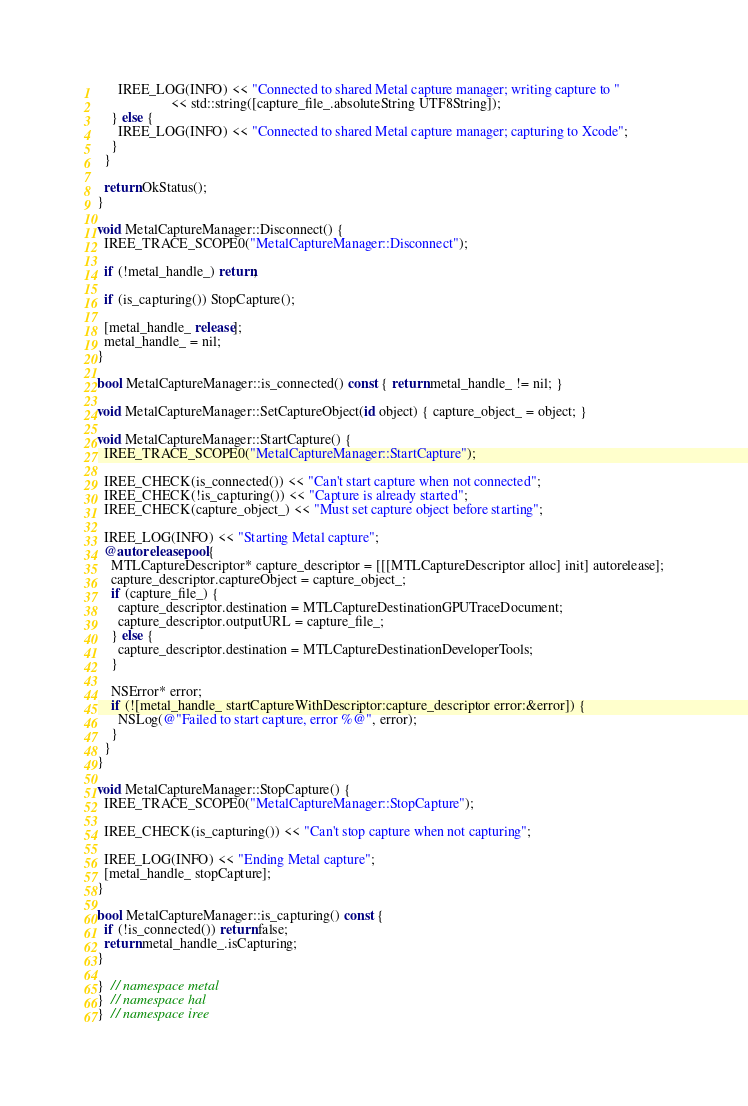Convert code to text. <code><loc_0><loc_0><loc_500><loc_500><_ObjectiveC_>      IREE_LOG(INFO) << "Connected to shared Metal capture manager; writing capture to "
                     << std::string([capture_file_.absoluteString UTF8String]);
    } else {
      IREE_LOG(INFO) << "Connected to shared Metal capture manager; capturing to Xcode";
    }
  }

  return OkStatus();
}

void MetalCaptureManager::Disconnect() {
  IREE_TRACE_SCOPE0("MetalCaptureManager::Disconnect");

  if (!metal_handle_) return;

  if (is_capturing()) StopCapture();

  [metal_handle_ release];
  metal_handle_ = nil;
}

bool MetalCaptureManager::is_connected() const { return metal_handle_ != nil; }

void MetalCaptureManager::SetCaptureObject(id object) { capture_object_ = object; }

void MetalCaptureManager::StartCapture() {
  IREE_TRACE_SCOPE0("MetalCaptureManager::StartCapture");

  IREE_CHECK(is_connected()) << "Can't start capture when not connected";
  IREE_CHECK(!is_capturing()) << "Capture is already started";
  IREE_CHECK(capture_object_) << "Must set capture object before starting";

  IREE_LOG(INFO) << "Starting Metal capture";
  @autoreleasepool {
    MTLCaptureDescriptor* capture_descriptor = [[[MTLCaptureDescriptor alloc] init] autorelease];
    capture_descriptor.captureObject = capture_object_;
    if (capture_file_) {
      capture_descriptor.destination = MTLCaptureDestinationGPUTraceDocument;
      capture_descriptor.outputURL = capture_file_;
    } else {
      capture_descriptor.destination = MTLCaptureDestinationDeveloperTools;
    }

    NSError* error;
    if (![metal_handle_ startCaptureWithDescriptor:capture_descriptor error:&error]) {
      NSLog(@"Failed to start capture, error %@", error);
    }
  }
}

void MetalCaptureManager::StopCapture() {
  IREE_TRACE_SCOPE0("MetalCaptureManager::StopCapture");

  IREE_CHECK(is_capturing()) << "Can't stop capture when not capturing";

  IREE_LOG(INFO) << "Ending Metal capture";
  [metal_handle_ stopCapture];
}

bool MetalCaptureManager::is_capturing() const {
  if (!is_connected()) return false;
  return metal_handle_.isCapturing;
}

}  // namespace metal
}  // namespace hal
}  // namespace iree
</code> 